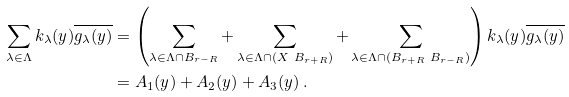<formula> <loc_0><loc_0><loc_500><loc_500>\sum _ { \lambda \in \Lambda } k _ { \lambda } ( y ) \overline { g _ { \lambda } ( y ) } & = \left ( \sum _ { \lambda \in \Lambda \cap B _ { r - R } } + \sum _ { \lambda \in \Lambda \cap ( X \ B _ { r + R } ) } + \sum _ { \lambda \in \Lambda \cap ( B _ { r + R } \ B _ { r - R } ) } \right ) k _ { \lambda } ( y ) \overline { g _ { \lambda } ( y ) } \\ & = A _ { 1 } ( y ) + A _ { 2 } ( y ) + A _ { 3 } ( y ) \, .</formula> 